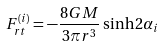Convert formula to latex. <formula><loc_0><loc_0><loc_500><loc_500>F ^ { ( i ) } _ { r t } = - \frac { 8 G M } { 3 \pi r ^ { 3 } } \sinh { 2 \alpha _ { i } }</formula> 